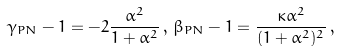Convert formula to latex. <formula><loc_0><loc_0><loc_500><loc_500>\gamma _ { P N } - 1 = - 2 \frac { \alpha ^ { 2 } } { 1 + \alpha ^ { 2 } } \, , \, \beta _ { P N } - 1 = \frac { \kappa \alpha ^ { 2 } } { ( 1 + \alpha ^ { 2 } ) ^ { 2 } } \, ,</formula> 